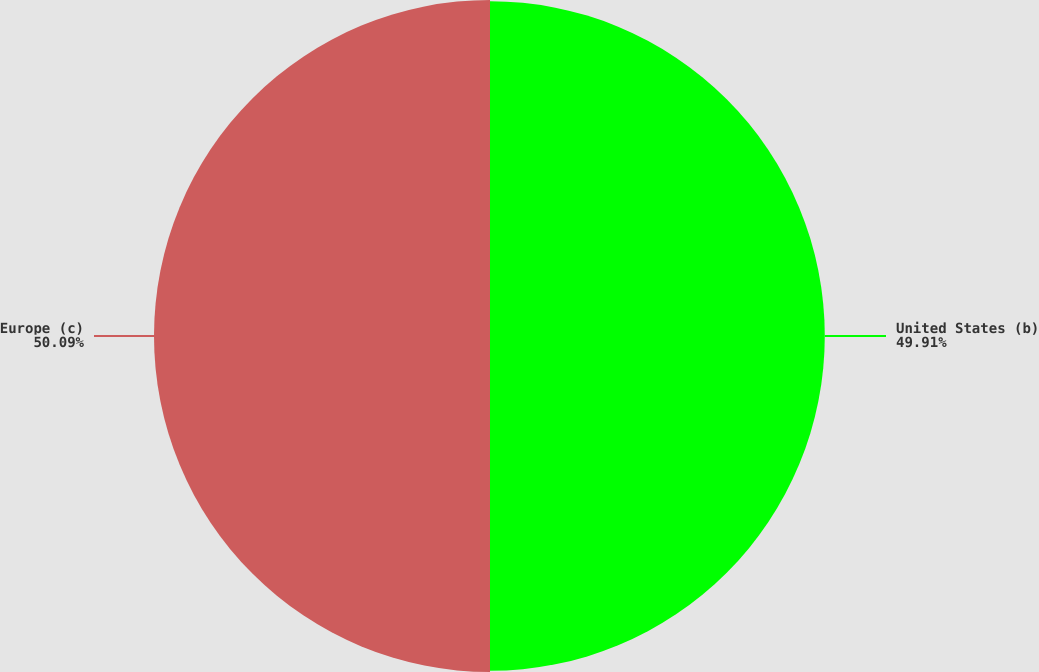Convert chart to OTSL. <chart><loc_0><loc_0><loc_500><loc_500><pie_chart><fcel>United States (b)<fcel>Europe (c)<nl><fcel>49.91%<fcel>50.09%<nl></chart> 